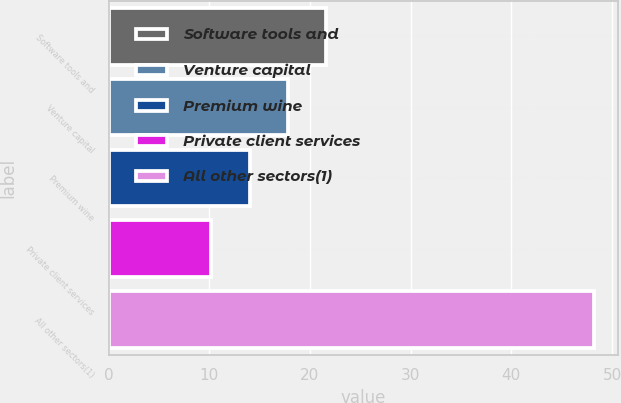Convert chart. <chart><loc_0><loc_0><loc_500><loc_500><bar_chart><fcel>Software tools and<fcel>Venture capital<fcel>Premium wine<fcel>Private client services<fcel>All other sectors(1)<nl><fcel>21.6<fcel>17.8<fcel>14<fcel>10.2<fcel>48.2<nl></chart> 